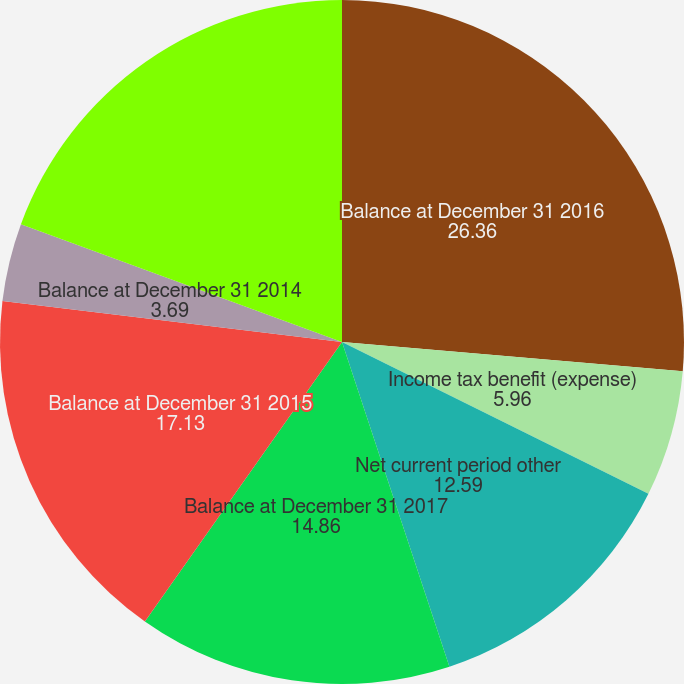Convert chart to OTSL. <chart><loc_0><loc_0><loc_500><loc_500><pie_chart><fcel>Balance at December 31 2016<fcel>Income tax benefit (expense)<fcel>Net current period other<fcel>Balance at December 31 2017<fcel>Balance at December 31 2015<fcel>Balance at December 31 2014<fcel>Other comprehensive income<nl><fcel>26.36%<fcel>5.96%<fcel>12.59%<fcel>14.86%<fcel>17.13%<fcel>3.69%<fcel>19.4%<nl></chart> 